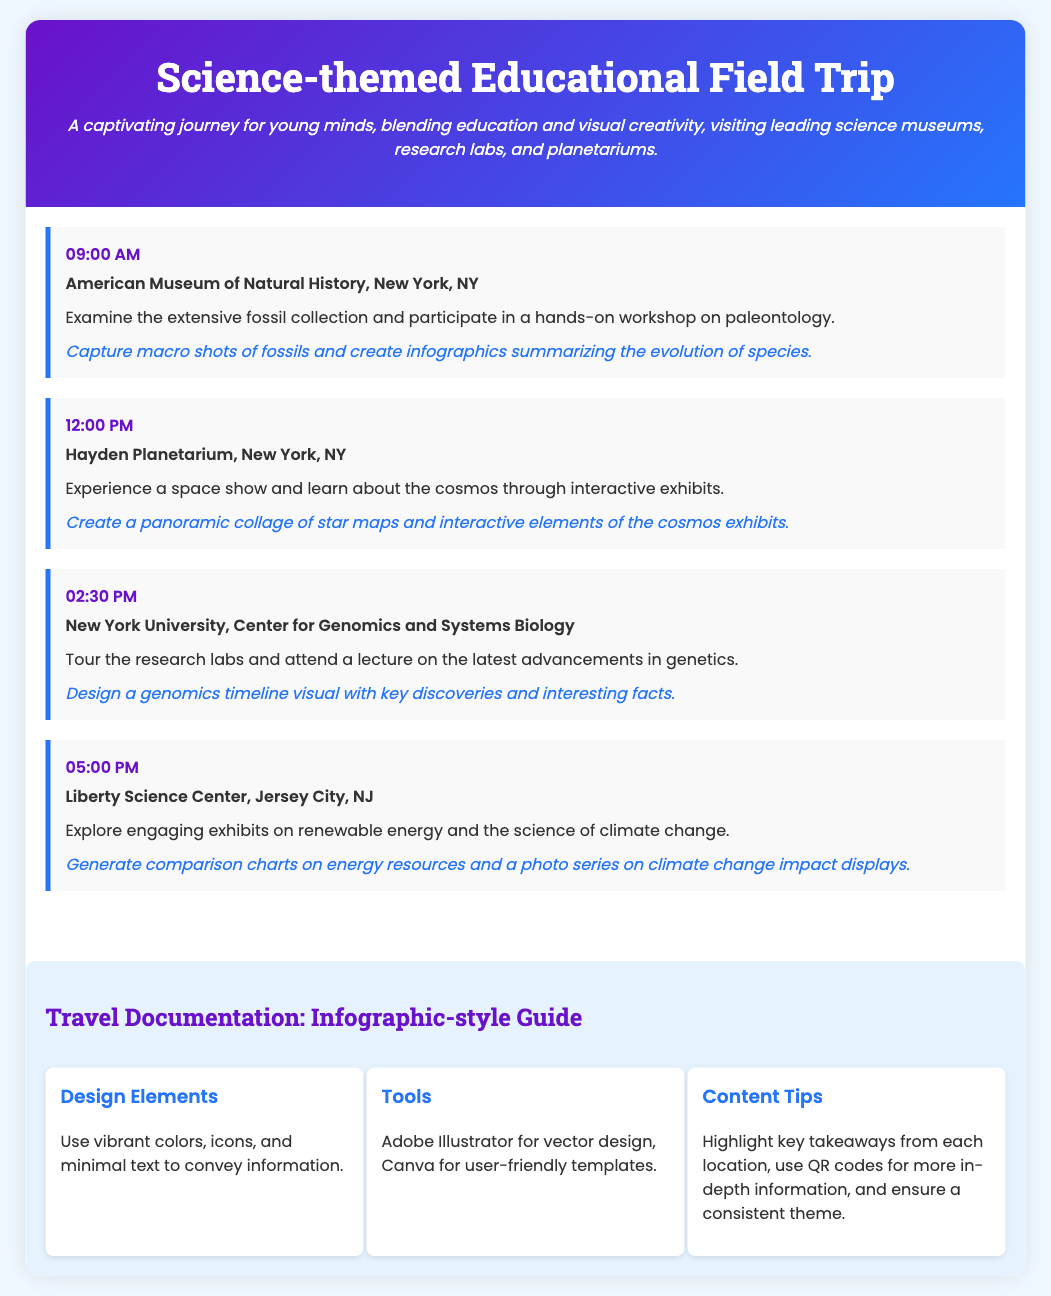What time does the first visit start? The first visit starts at 09:00 AM as listed in the schedule.
Answer: 09:00 AM Where is the first location visited? The first location visited is the American Museum of Natural History in New York, NY.
Answer: American Museum of Natural History, New York, NY What is one activity at the Hayden Planetarium? One activity at the Hayden Planetarium is experiencing a space show.
Answer: Experience a space show What are two visual suggestions made for the Liberty Science Center? Visual suggestions for the Liberty Science Center include generating comparison charts and a photo series.
Answer: Comparison charts, photo series What tool is recommended for design? Adobe Illustrator is recommended for vector design.
Answer: Adobe Illustrator How many places are scheduled for visits? There are four places scheduled for visits in the itinerary.
Answer: Four What is the main theme of the field trip? The main theme of the field trip is science-themed education.
Answer: Science-themed education Which center is visited at 02:30 PM? The center visited at 02:30 PM is New York University, Center for Genomics and Systems Biology.
Answer: New York University, Center for Genomics and Systems Biology 